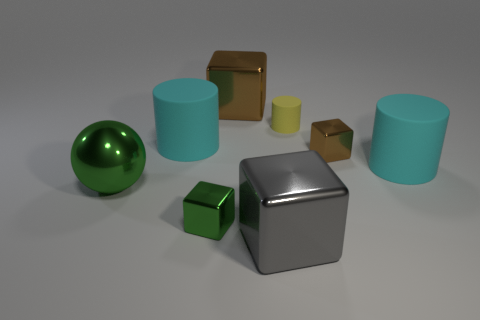What could be the purpose of this arrangement? This assembly of objects could serve several purposes. Aesthetically, it has a modern, minimalist feel, and it could be part of a visual art display or a scene from a computer graphics portfolio. Functionally, it might be an educational setup demonstrating shapes, materials, and shadows in photography or 3D rendering tutorials. 